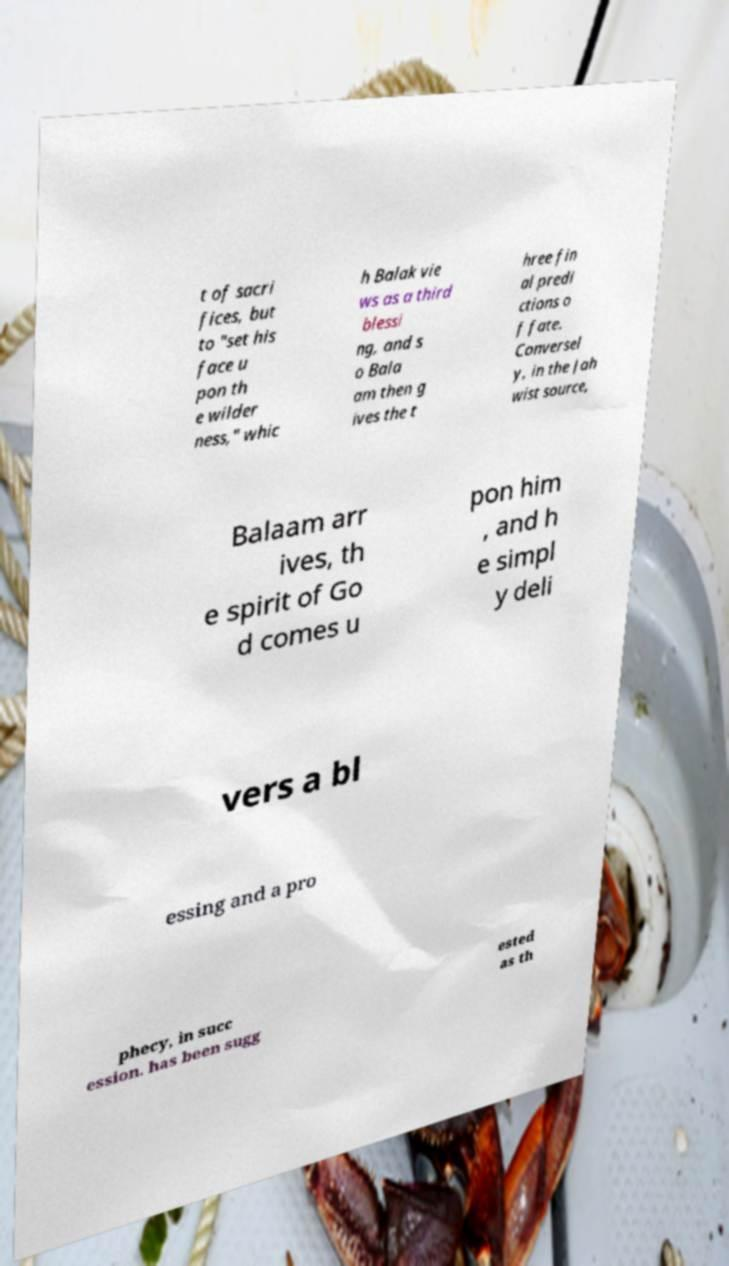For documentation purposes, I need the text within this image transcribed. Could you provide that? t of sacri fices, but to "set his face u pon th e wilder ness," whic h Balak vie ws as a third blessi ng, and s o Bala am then g ives the t hree fin al predi ctions o f fate. Conversel y, in the Jah wist source, Balaam arr ives, th e spirit of Go d comes u pon him , and h e simpl y deli vers a bl essing and a pro phecy, in succ ession. has been sugg ested as th 